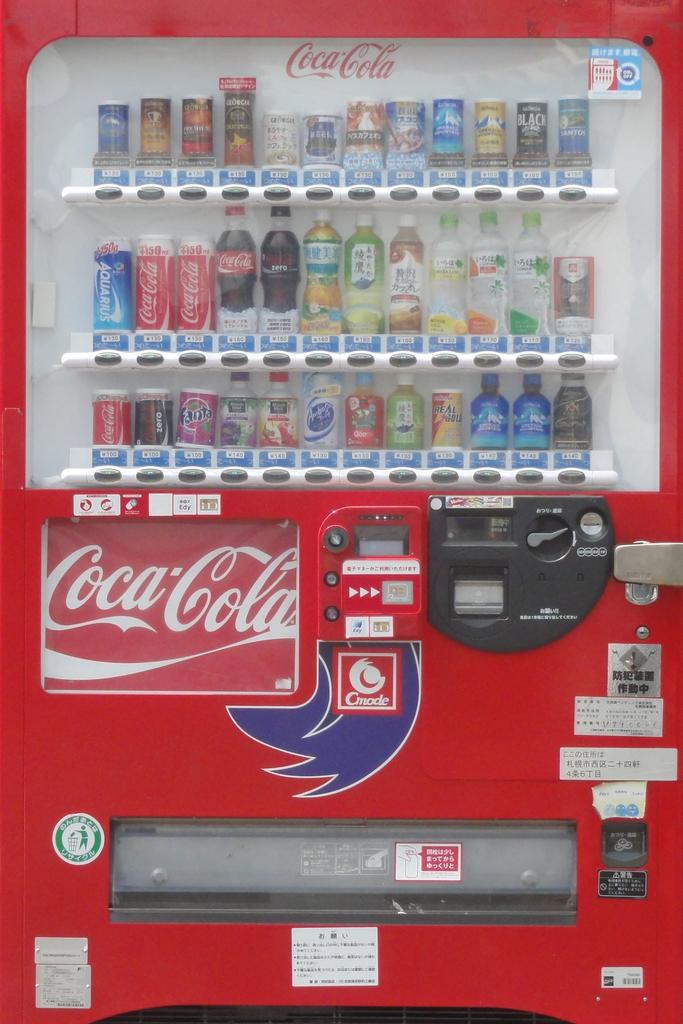Provide a one-sentence caption for the provided image. A Coca Cola vending machine with many drinks inside. 